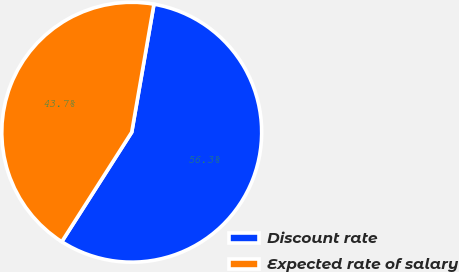<chart> <loc_0><loc_0><loc_500><loc_500><pie_chart><fcel>Discount rate<fcel>Expected rate of salary<nl><fcel>56.31%<fcel>43.69%<nl></chart> 